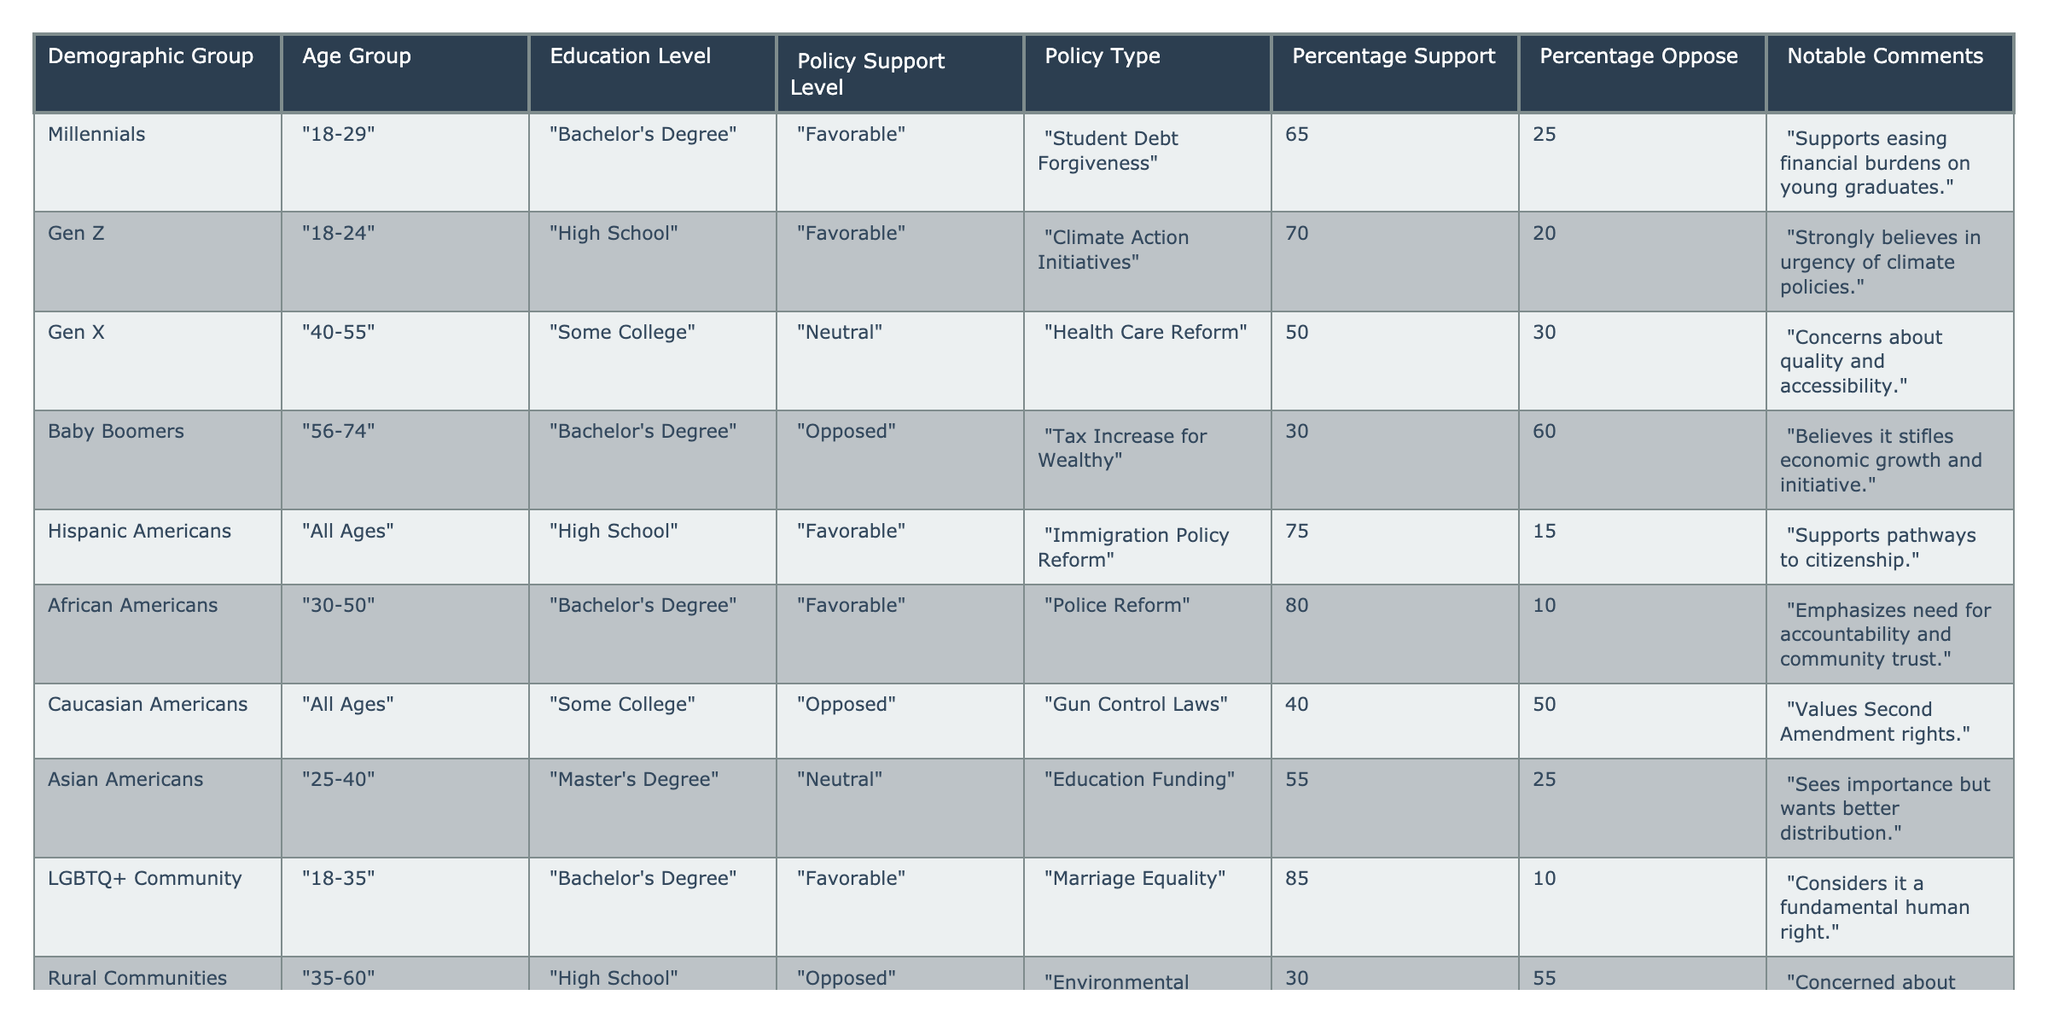What is the percentage of support for Student Debt Forgiveness among Millennials? From the table, the percentage support for Student Debt Forgiveness among Millennials is directly listed as 65%.
Answer: 65% Which demographic group shows the highest support for Marriage Equality? The LGBTQ+ Community has a support level of 85% for Marriage Equality, which is higher than any other group in the table.
Answer: LGBTQ+ Community How many demographic groups are favorable toward Climate Action Initiatives? The only group listed as favorable toward Climate Action Initiatives is Gen Z, so there is one favorable group.
Answer: 1 What is the difference in percentage support for Gun Control Laws between Caucasian Americans and the general opposition level? Caucasian Americans have a 40% support level for Gun Control Laws, with 50% opposing. The difference is 50% - 40% = 10%.
Answer: 10% Is there a demographic group that shows universal support across all age groups for Immigration Policy Reform? Yes, Hispanic Americans show favorable support across all ages for Immigration Policy Reform at 75%.
Answer: Yes What is the average percentage of support across all demographic groups for Health Care Reform? The support for Health Care Reform is 50% from Gen X. Since this is the only recorded value, the average support is also 50%.
Answer: 50% Which age group has the highest percentage of support for Climate Action Initiatives? Gen Z in the age group 18-24 has the highest support at 70% for Climate Action Initiatives, which is the only figure provided for this policy.
Answer: 70% What percentage of Baby Boomers oppose the Tax Increase for the Wealthy? The table indicates that 60% of Baby Boomers oppose the Tax Increase for the Wealthy directly.
Answer: 60% Which demographic group demonstrates the least support for Environmental Regulations? Rural Communities, with a support level of 30%, show the least support for Environmental Regulations.
Answer: Rural Communities Considering the data, how does the level of support for Student Debt Forgiveness compare to the level of support for Police Reform among African Americans? Police Reform has 80% support among African Americans, while Student Debt Forgiveness has 65% support among Millennials, indicating that Police Reform has 15% higher support.
Answer: 15% higher 